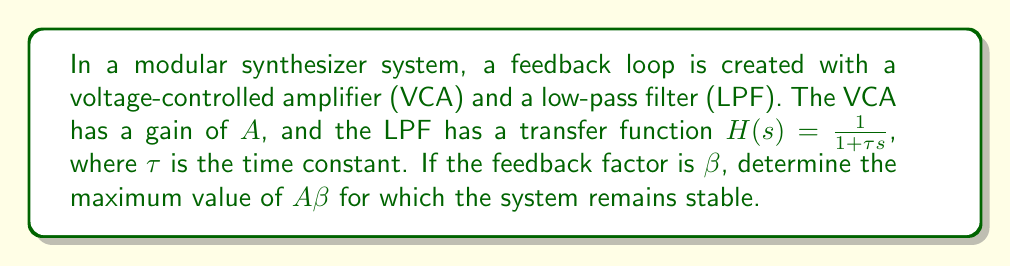Can you answer this question? To determine the stability of the feedback loop, we need to analyze the loop gain:

1. The open-loop transfer function is:
   $$G(s) = A \cdot H(s) = \frac{A}{1 + \tau s}$$

2. The closed-loop transfer function is:
   $$T(s) = \frac{G(s)}{1 + \beta G(s)} = \frac{A}{1 + \tau s + A\beta}$$

3. For stability, all poles of $T(s)$ must have negative real parts. The characteristic equation is:
   $$1 + \tau s + A\beta = 0$$

4. Solving for $s$:
   $$s = -\frac{1}{\tau} + \frac{A\beta}{\tau}$$

5. For stability, we require:
   $$-\frac{1}{\tau} + \frac{A\beta}{\tau} < 0$$

6. Simplifying:
   $$A\beta < 1$$

Therefore, the maximum value of $A\beta$ for which the system remains stable is 1.
Answer: $A\beta < 1$ 